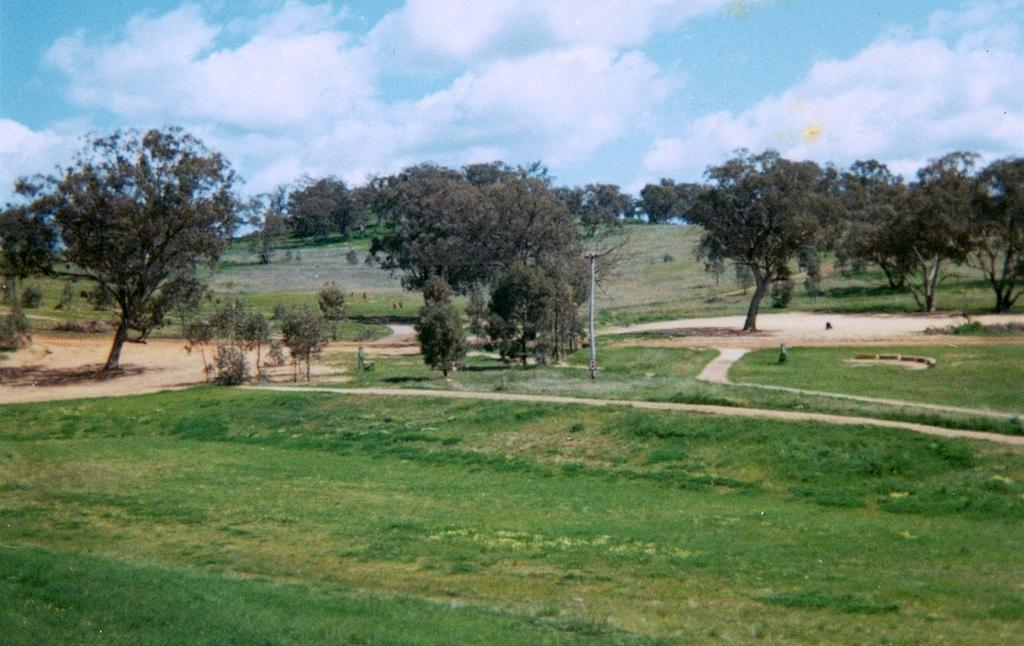What type of surface is visible in the image? There is ground visible in the image. What type of vegetation is present in the image? There is grass in the image. What type of man-made structure can be seen in the image? There is a road and a pole in the image. What type of natural structures are present in the image? There are trees in the image. What is visible in the background of the image? There are trees and the sky visible in the background of the image. How many cattle are grazing in the image? There are no cattle present in the image. What type of toothbrush is hanging on the pole in the image? There is no toothbrush present in the image. 